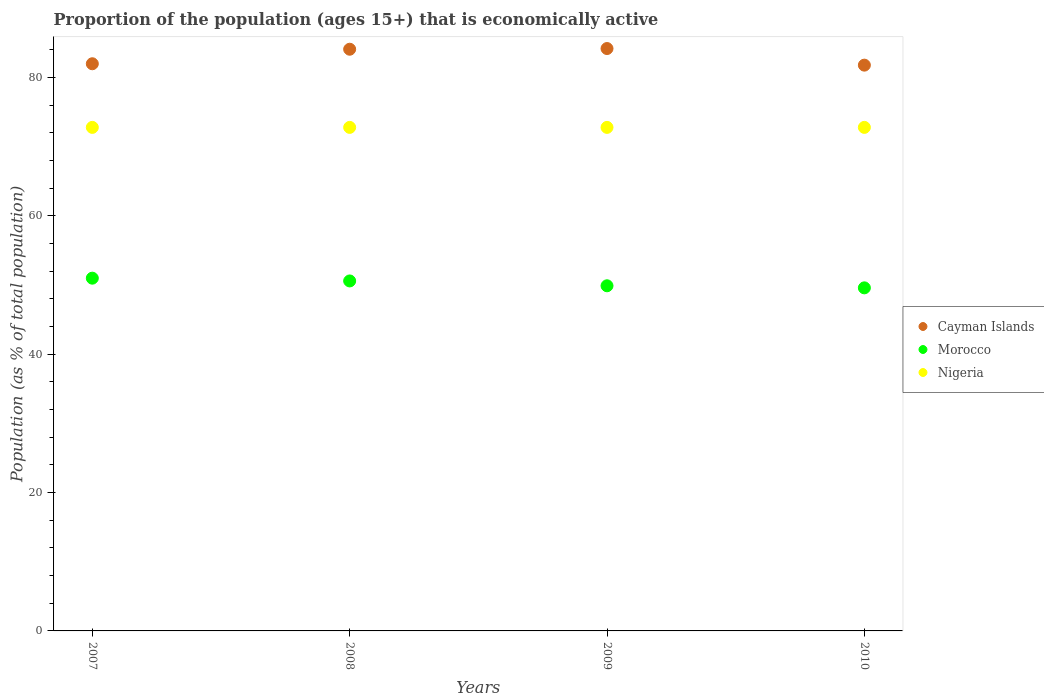Is the number of dotlines equal to the number of legend labels?
Your answer should be compact. Yes. What is the proportion of the population that is economically active in Nigeria in 2009?
Your answer should be very brief. 72.8. Across all years, what is the maximum proportion of the population that is economically active in Nigeria?
Your answer should be compact. 72.8. Across all years, what is the minimum proportion of the population that is economically active in Cayman Islands?
Provide a succinct answer. 81.8. In which year was the proportion of the population that is economically active in Nigeria maximum?
Offer a very short reply. 2007. In which year was the proportion of the population that is economically active in Morocco minimum?
Offer a very short reply. 2010. What is the total proportion of the population that is economically active in Morocco in the graph?
Your response must be concise. 201.1. What is the difference between the proportion of the population that is economically active in Morocco in 2008 and the proportion of the population that is economically active in Cayman Islands in 2009?
Your response must be concise. -33.6. What is the average proportion of the population that is economically active in Morocco per year?
Keep it short and to the point. 50.27. What is the ratio of the proportion of the population that is economically active in Morocco in 2008 to that in 2010?
Ensure brevity in your answer.  1.02. Is the proportion of the population that is economically active in Cayman Islands in 2007 less than that in 2009?
Ensure brevity in your answer.  Yes. Is the difference between the proportion of the population that is economically active in Cayman Islands in 2008 and 2009 greater than the difference between the proportion of the population that is economically active in Morocco in 2008 and 2009?
Offer a terse response. No. What is the difference between the highest and the second highest proportion of the population that is economically active in Nigeria?
Keep it short and to the point. 0. What is the difference between the highest and the lowest proportion of the population that is economically active in Morocco?
Your answer should be very brief. 1.4. Is it the case that in every year, the sum of the proportion of the population that is economically active in Cayman Islands and proportion of the population that is economically active in Morocco  is greater than the proportion of the population that is economically active in Nigeria?
Make the answer very short. Yes. Is the proportion of the population that is economically active in Cayman Islands strictly greater than the proportion of the population that is economically active in Morocco over the years?
Ensure brevity in your answer.  Yes. Is the proportion of the population that is economically active in Morocco strictly less than the proportion of the population that is economically active in Nigeria over the years?
Give a very brief answer. Yes. How many dotlines are there?
Ensure brevity in your answer.  3. How many years are there in the graph?
Make the answer very short. 4. What is the difference between two consecutive major ticks on the Y-axis?
Ensure brevity in your answer.  20. Are the values on the major ticks of Y-axis written in scientific E-notation?
Keep it short and to the point. No. Does the graph contain any zero values?
Your response must be concise. No. How many legend labels are there?
Provide a short and direct response. 3. What is the title of the graph?
Ensure brevity in your answer.  Proportion of the population (ages 15+) that is economically active. What is the label or title of the Y-axis?
Give a very brief answer. Population (as % of total population). What is the Population (as % of total population) in Cayman Islands in 2007?
Keep it short and to the point. 82. What is the Population (as % of total population) of Nigeria in 2007?
Your response must be concise. 72.8. What is the Population (as % of total population) in Cayman Islands in 2008?
Your answer should be compact. 84.1. What is the Population (as % of total population) in Morocco in 2008?
Your answer should be very brief. 50.6. What is the Population (as % of total population) in Nigeria in 2008?
Your response must be concise. 72.8. What is the Population (as % of total population) of Cayman Islands in 2009?
Your answer should be compact. 84.2. What is the Population (as % of total population) in Morocco in 2009?
Ensure brevity in your answer.  49.9. What is the Population (as % of total population) in Nigeria in 2009?
Your answer should be very brief. 72.8. What is the Population (as % of total population) in Cayman Islands in 2010?
Provide a succinct answer. 81.8. What is the Population (as % of total population) of Morocco in 2010?
Your answer should be compact. 49.6. What is the Population (as % of total population) of Nigeria in 2010?
Provide a short and direct response. 72.8. Across all years, what is the maximum Population (as % of total population) of Cayman Islands?
Your answer should be very brief. 84.2. Across all years, what is the maximum Population (as % of total population) of Nigeria?
Your answer should be very brief. 72.8. Across all years, what is the minimum Population (as % of total population) in Cayman Islands?
Offer a terse response. 81.8. Across all years, what is the minimum Population (as % of total population) of Morocco?
Offer a terse response. 49.6. Across all years, what is the minimum Population (as % of total population) in Nigeria?
Keep it short and to the point. 72.8. What is the total Population (as % of total population) of Cayman Islands in the graph?
Ensure brevity in your answer.  332.1. What is the total Population (as % of total population) in Morocco in the graph?
Offer a very short reply. 201.1. What is the total Population (as % of total population) of Nigeria in the graph?
Make the answer very short. 291.2. What is the difference between the Population (as % of total population) in Cayman Islands in 2007 and that in 2008?
Give a very brief answer. -2.1. What is the difference between the Population (as % of total population) of Morocco in 2007 and that in 2008?
Make the answer very short. 0.4. What is the difference between the Population (as % of total population) of Nigeria in 2007 and that in 2008?
Your answer should be very brief. 0. What is the difference between the Population (as % of total population) of Cayman Islands in 2007 and that in 2009?
Your answer should be very brief. -2.2. What is the difference between the Population (as % of total population) of Cayman Islands in 2007 and that in 2010?
Offer a very short reply. 0.2. What is the difference between the Population (as % of total population) of Morocco in 2007 and that in 2010?
Your response must be concise. 1.4. What is the difference between the Population (as % of total population) of Cayman Islands in 2008 and that in 2009?
Give a very brief answer. -0.1. What is the difference between the Population (as % of total population) in Nigeria in 2008 and that in 2009?
Provide a succinct answer. 0. What is the difference between the Population (as % of total population) of Cayman Islands in 2008 and that in 2010?
Make the answer very short. 2.3. What is the difference between the Population (as % of total population) of Morocco in 2008 and that in 2010?
Your answer should be very brief. 1. What is the difference between the Population (as % of total population) in Cayman Islands in 2007 and the Population (as % of total population) in Morocco in 2008?
Ensure brevity in your answer.  31.4. What is the difference between the Population (as % of total population) in Cayman Islands in 2007 and the Population (as % of total population) in Nigeria in 2008?
Keep it short and to the point. 9.2. What is the difference between the Population (as % of total population) of Morocco in 2007 and the Population (as % of total population) of Nigeria in 2008?
Your answer should be very brief. -21.8. What is the difference between the Population (as % of total population) in Cayman Islands in 2007 and the Population (as % of total population) in Morocco in 2009?
Offer a very short reply. 32.1. What is the difference between the Population (as % of total population) of Morocco in 2007 and the Population (as % of total population) of Nigeria in 2009?
Your answer should be compact. -21.8. What is the difference between the Population (as % of total population) of Cayman Islands in 2007 and the Population (as % of total population) of Morocco in 2010?
Ensure brevity in your answer.  32.4. What is the difference between the Population (as % of total population) in Morocco in 2007 and the Population (as % of total population) in Nigeria in 2010?
Offer a terse response. -21.8. What is the difference between the Population (as % of total population) in Cayman Islands in 2008 and the Population (as % of total population) in Morocco in 2009?
Offer a very short reply. 34.2. What is the difference between the Population (as % of total population) of Cayman Islands in 2008 and the Population (as % of total population) of Nigeria in 2009?
Make the answer very short. 11.3. What is the difference between the Population (as % of total population) in Morocco in 2008 and the Population (as % of total population) in Nigeria in 2009?
Provide a succinct answer. -22.2. What is the difference between the Population (as % of total population) in Cayman Islands in 2008 and the Population (as % of total population) in Morocco in 2010?
Provide a short and direct response. 34.5. What is the difference between the Population (as % of total population) in Cayman Islands in 2008 and the Population (as % of total population) in Nigeria in 2010?
Your answer should be compact. 11.3. What is the difference between the Population (as % of total population) in Morocco in 2008 and the Population (as % of total population) in Nigeria in 2010?
Your answer should be very brief. -22.2. What is the difference between the Population (as % of total population) of Cayman Islands in 2009 and the Population (as % of total population) of Morocco in 2010?
Give a very brief answer. 34.6. What is the difference between the Population (as % of total population) in Morocco in 2009 and the Population (as % of total population) in Nigeria in 2010?
Make the answer very short. -22.9. What is the average Population (as % of total population) in Cayman Islands per year?
Provide a succinct answer. 83.03. What is the average Population (as % of total population) in Morocco per year?
Keep it short and to the point. 50.27. What is the average Population (as % of total population) of Nigeria per year?
Ensure brevity in your answer.  72.8. In the year 2007, what is the difference between the Population (as % of total population) of Cayman Islands and Population (as % of total population) of Morocco?
Ensure brevity in your answer.  31. In the year 2007, what is the difference between the Population (as % of total population) of Cayman Islands and Population (as % of total population) of Nigeria?
Provide a short and direct response. 9.2. In the year 2007, what is the difference between the Population (as % of total population) of Morocco and Population (as % of total population) of Nigeria?
Provide a short and direct response. -21.8. In the year 2008, what is the difference between the Population (as % of total population) in Cayman Islands and Population (as % of total population) in Morocco?
Offer a very short reply. 33.5. In the year 2008, what is the difference between the Population (as % of total population) of Morocco and Population (as % of total population) of Nigeria?
Provide a short and direct response. -22.2. In the year 2009, what is the difference between the Population (as % of total population) in Cayman Islands and Population (as % of total population) in Morocco?
Your answer should be compact. 34.3. In the year 2009, what is the difference between the Population (as % of total population) of Cayman Islands and Population (as % of total population) of Nigeria?
Offer a very short reply. 11.4. In the year 2009, what is the difference between the Population (as % of total population) in Morocco and Population (as % of total population) in Nigeria?
Provide a succinct answer. -22.9. In the year 2010, what is the difference between the Population (as % of total population) of Cayman Islands and Population (as % of total population) of Morocco?
Your answer should be compact. 32.2. In the year 2010, what is the difference between the Population (as % of total population) of Morocco and Population (as % of total population) of Nigeria?
Keep it short and to the point. -23.2. What is the ratio of the Population (as % of total population) in Cayman Islands in 2007 to that in 2008?
Your response must be concise. 0.97. What is the ratio of the Population (as % of total population) in Morocco in 2007 to that in 2008?
Offer a terse response. 1.01. What is the ratio of the Population (as % of total population) in Cayman Islands in 2007 to that in 2009?
Provide a succinct answer. 0.97. What is the ratio of the Population (as % of total population) of Morocco in 2007 to that in 2009?
Your answer should be compact. 1.02. What is the ratio of the Population (as % of total population) in Morocco in 2007 to that in 2010?
Your response must be concise. 1.03. What is the ratio of the Population (as % of total population) in Nigeria in 2007 to that in 2010?
Keep it short and to the point. 1. What is the ratio of the Population (as % of total population) in Cayman Islands in 2008 to that in 2009?
Your response must be concise. 1. What is the ratio of the Population (as % of total population) in Morocco in 2008 to that in 2009?
Ensure brevity in your answer.  1.01. What is the ratio of the Population (as % of total population) in Cayman Islands in 2008 to that in 2010?
Keep it short and to the point. 1.03. What is the ratio of the Population (as % of total population) of Morocco in 2008 to that in 2010?
Ensure brevity in your answer.  1.02. What is the ratio of the Population (as % of total population) in Nigeria in 2008 to that in 2010?
Your answer should be very brief. 1. What is the ratio of the Population (as % of total population) of Cayman Islands in 2009 to that in 2010?
Provide a succinct answer. 1.03. What is the difference between the highest and the second highest Population (as % of total population) of Morocco?
Your response must be concise. 0.4. What is the difference between the highest and the lowest Population (as % of total population) in Cayman Islands?
Your answer should be very brief. 2.4. What is the difference between the highest and the lowest Population (as % of total population) of Morocco?
Your answer should be very brief. 1.4. 